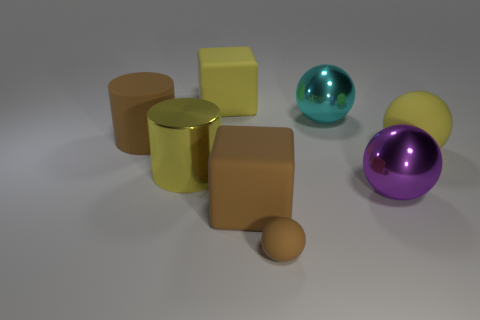What is the material of the purple thing that is the same size as the brown rubber cube?
Offer a very short reply. Metal. There is a yellow matte object that is on the right side of the small rubber object; what is its size?
Provide a succinct answer. Large. What is the size of the brown cylinder?
Provide a short and direct response. Large. There is a purple shiny thing; is it the same size as the metallic object that is behind the metallic cylinder?
Keep it short and to the point. Yes. There is a rubber block behind the large purple shiny object right of the small object; what color is it?
Your answer should be compact. Yellow. Are there the same number of large purple things to the right of the small sphere and brown matte things behind the big yellow metal thing?
Give a very brief answer. Yes. Does the big cube behind the brown block have the same material as the tiny brown thing?
Provide a succinct answer. Yes. What is the color of the big matte thing that is left of the brown cube and in front of the big yellow matte block?
Your answer should be very brief. Brown. What number of large cyan metallic spheres are on the right side of the matte thing that is right of the purple thing?
Ensure brevity in your answer.  0. There is a large yellow thing that is the same shape as the tiny brown object; what is it made of?
Provide a succinct answer. Rubber. 